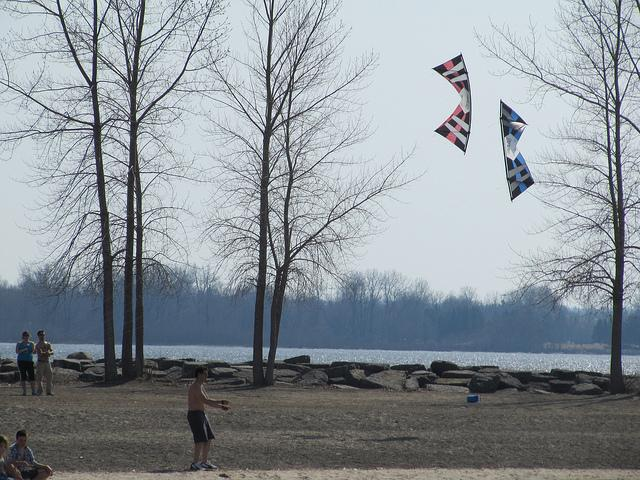What are the kites in most danger of getting stuck in? trees 